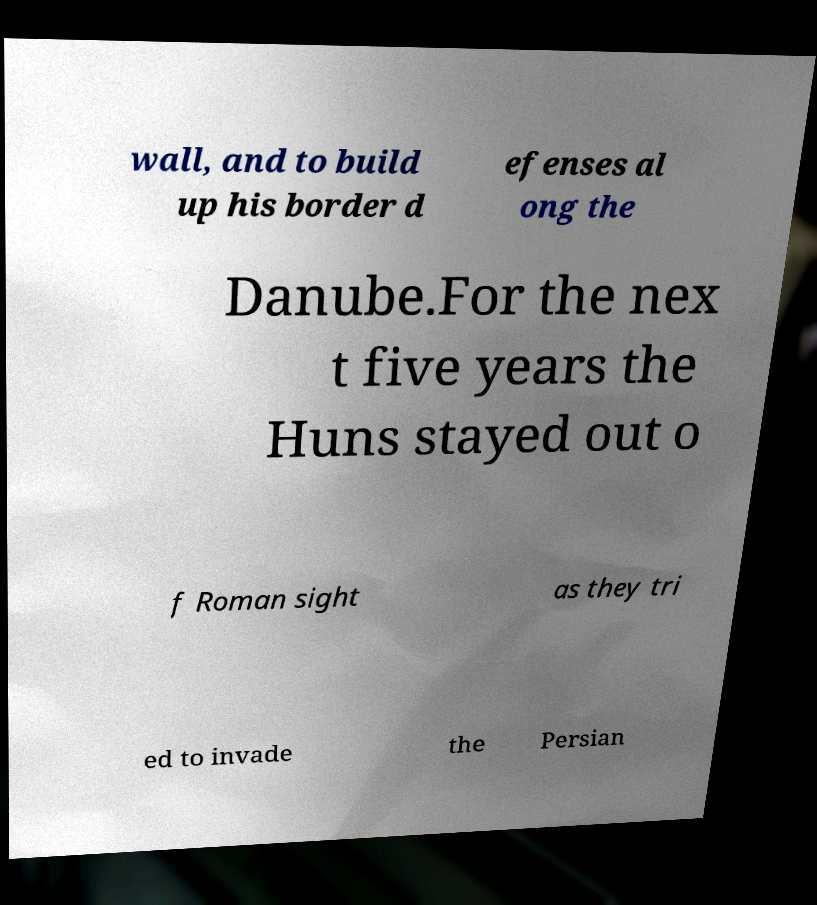For documentation purposes, I need the text within this image transcribed. Could you provide that? wall, and to build up his border d efenses al ong the Danube.For the nex t five years the Huns stayed out o f Roman sight as they tri ed to invade the Persian 